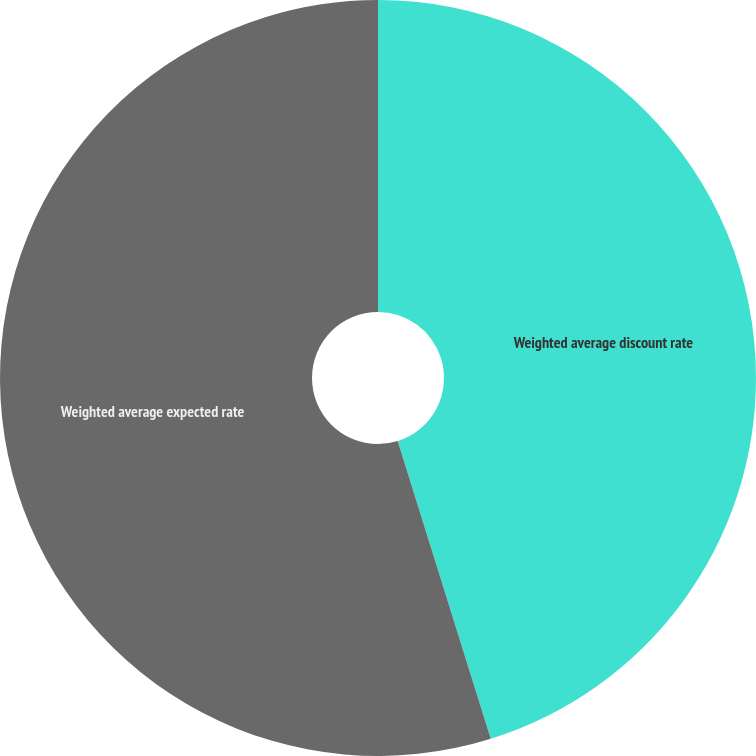Convert chart. <chart><loc_0><loc_0><loc_500><loc_500><pie_chart><fcel>Weighted average discount rate<fcel>Weighted average expected rate<nl><fcel>45.18%<fcel>54.82%<nl></chart> 